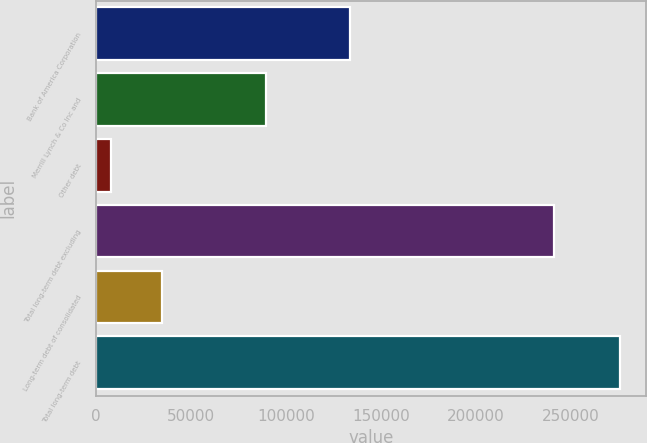Convert chart. <chart><loc_0><loc_0><loc_500><loc_500><bar_chart><fcel>Bank of America Corporation<fcel>Merrill Lynch & Co Inc and<fcel>Other debt<fcel>Total long-term debt excluding<fcel>Long-term debt of consolidated<fcel>Total long-term debt<nl><fcel>133939<fcel>89766<fcel>8129<fcel>241329<fcel>34874.6<fcel>275585<nl></chart> 